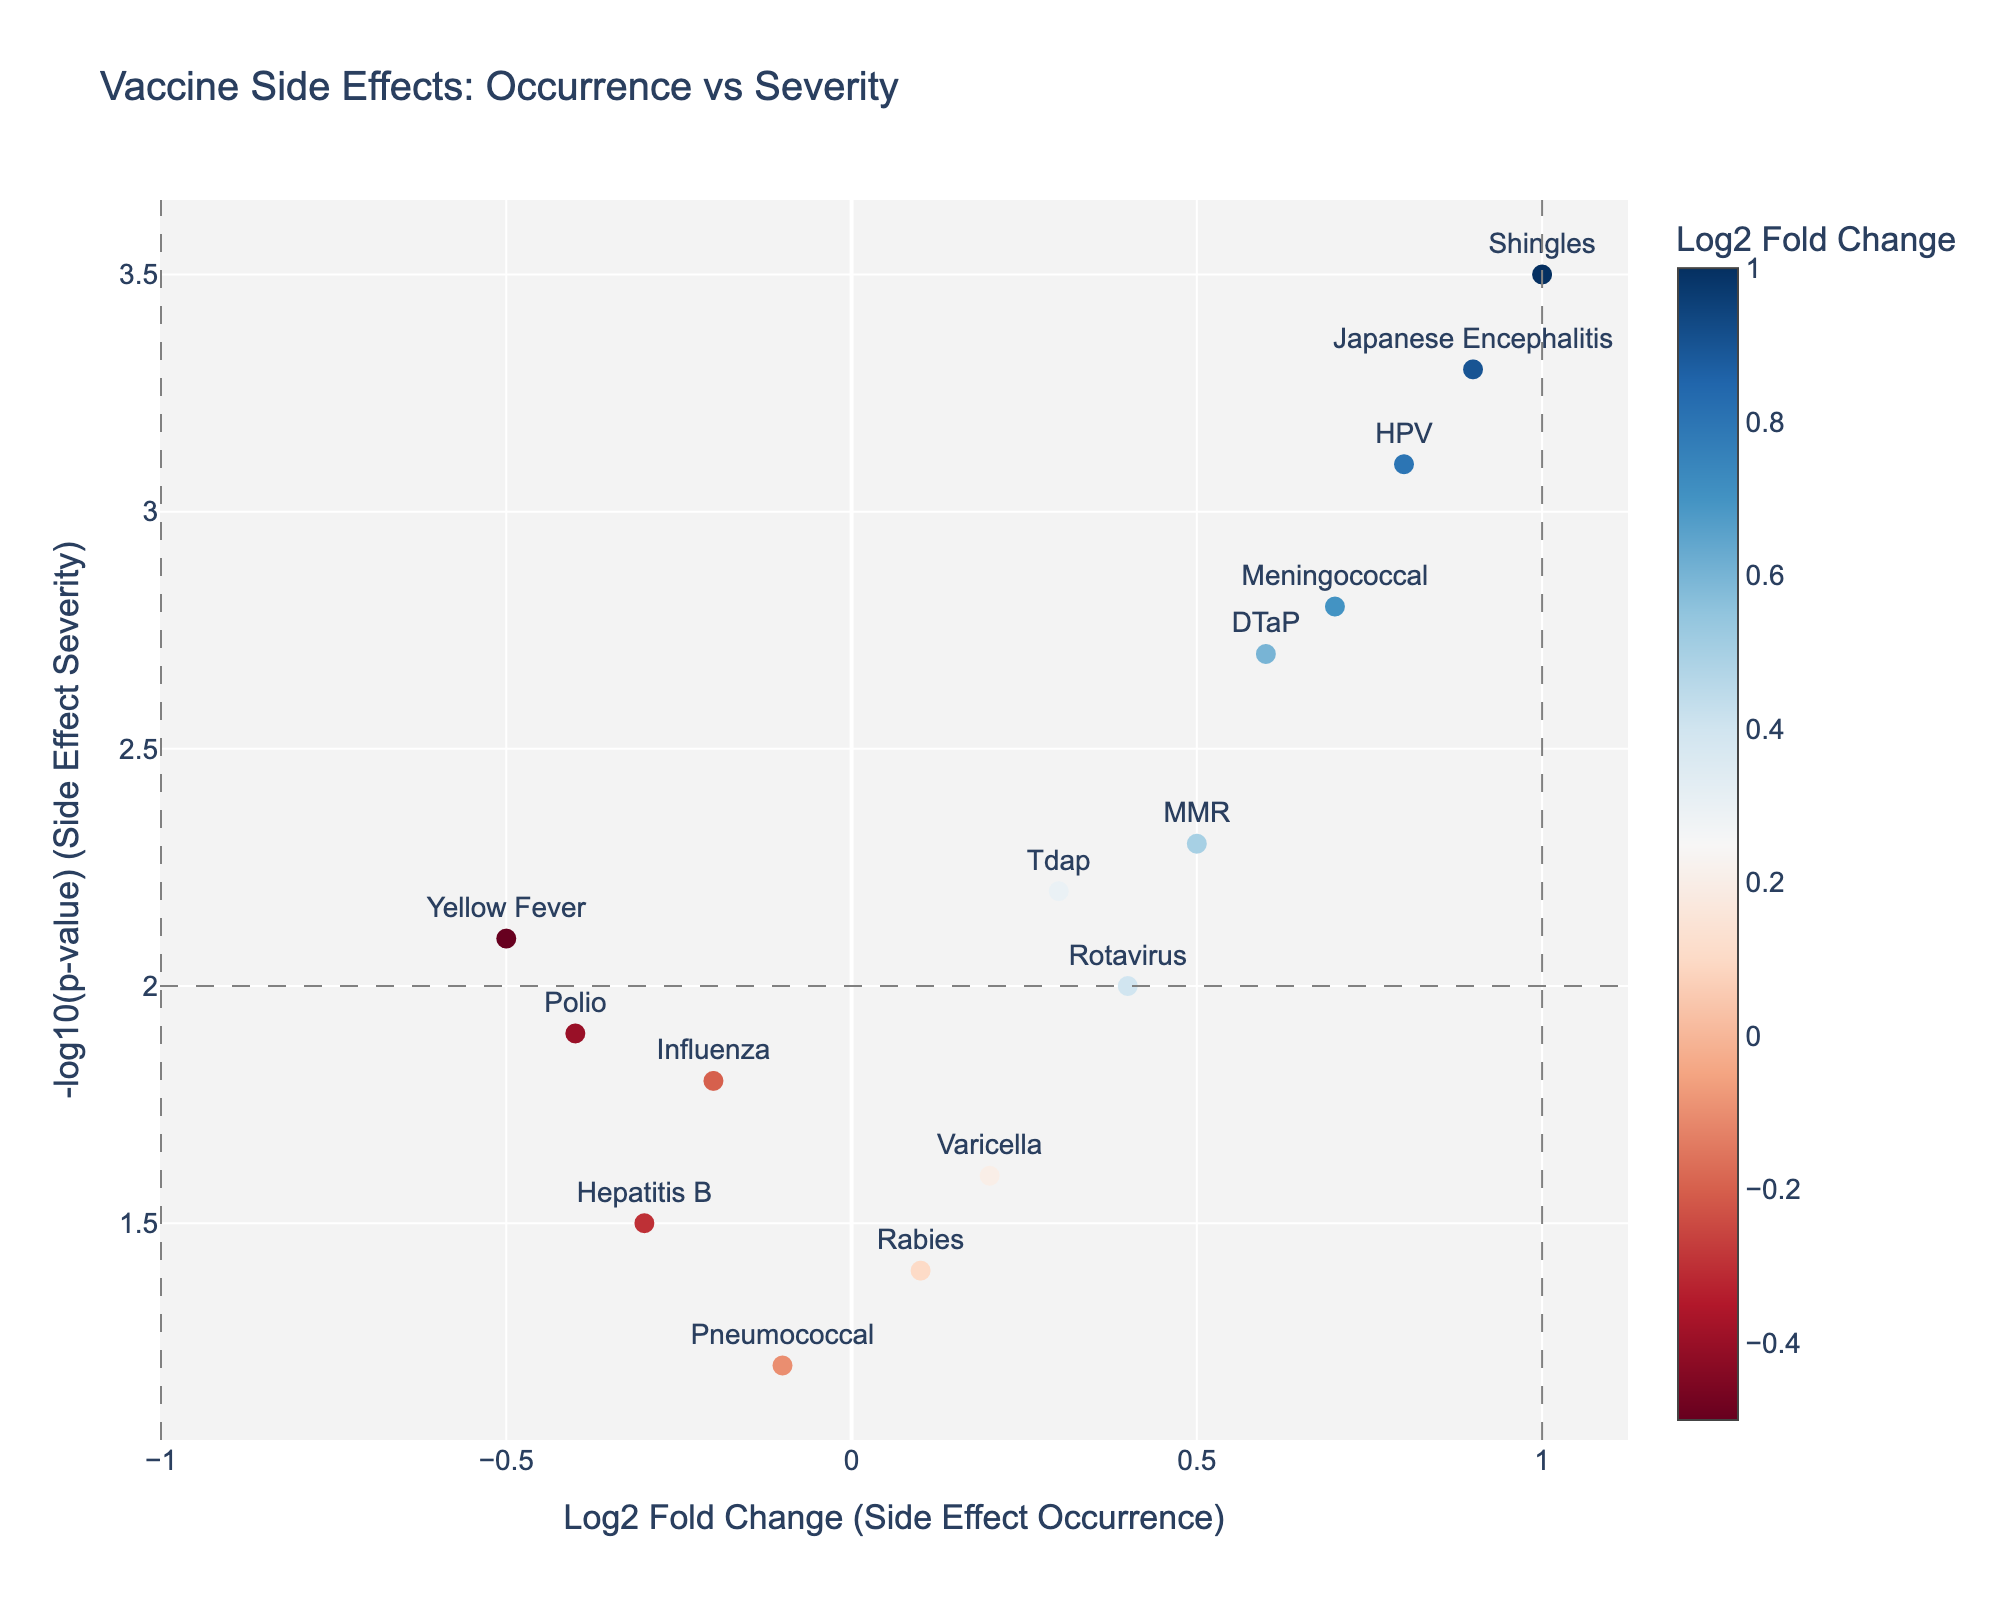Which vaccine shows the highest value on the y-axis? The y-axis represents -log10(p-value). The highest value corresponds to the Shingles vaccine, which reaches 3.5.
Answer: Shingles Which vaccine has the highest log2 fold change in side effect occurrence? The x-axis represents the log2 fold change. The vaccine with the highest value is the Shingles vaccine at 1.0.
Answer: Shingles Which vaccines fall within the central region (between the vertical lines at -1 and 1) and above the horizontal line (y=2)? The vaccines falling in this region have log2 fold changes between -1 and 1 and -log10(p-values) above 2. These are MMR, DTaP, Meningococcal, and Japanese Encephalitis.
Answer: MMR, DTaP, Meningococcal, Japanese Encephalitis Are there any vaccines that have both log2 fold change less than -1 and -log10(p-value) greater than 2? None of the vaccines fall in the region with log2 fold change less than -1 and -log10(p-values) greater than 2. All such values are to the right of x=-1.
Answer: No What's the average -log10(p-value) for Influenza, Polio, and Rabies vaccines? The -log10(p-values) for Influenza, Polio, and Rabies are 1.8, 1.9, and 1.4 respectively. The average is (1.8 + 1.9 + 1.4) / 3 = 1.7.
Answer: 1.7 Which vaccines have negative log2 fold changes? How many are they? Negative log2 fold changes indicate reduced side effect occurrences. The vaccines with negative log2 fold changes are Influenza, Hepatitis B, Pneumococcal, Polio, and Yellow Fever. There are 5 such vaccines.
Answer: 5 Which vaccines have a -log10(p-value) greater than 3? The vaccines exceeding a -log10(p-value) of 3 include HPV, Shingles, and Japanese Encephalitis.
Answer: HPV, Shingles, Japanese Encephalitis What is the log2 fold change and -log10(p-value) for DTaP? DTaP's log2 fold change is 0.6, and its -log10(p-value) is 2.7.
Answer: 0.6, 2.7 